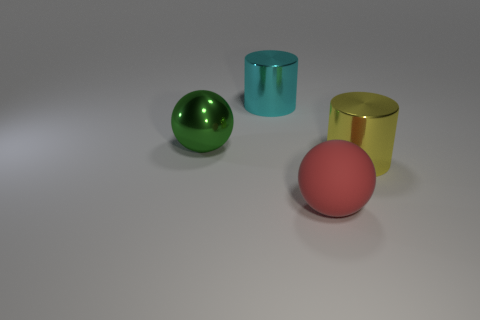Add 4 large green metal objects. How many objects exist? 8 Add 4 cyan things. How many cyan things are left? 5 Add 4 red objects. How many red objects exist? 5 Subtract 0 yellow blocks. How many objects are left? 4 Subtract all large cyan metallic cylinders. Subtract all green things. How many objects are left? 2 